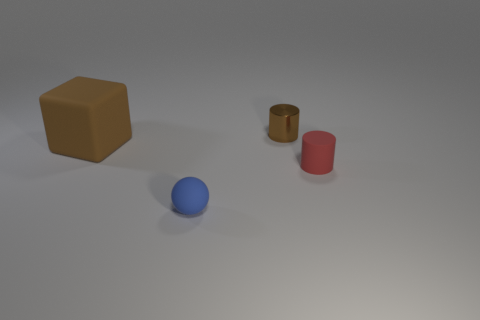Add 2 tiny cyan things. How many objects exist? 6 Subtract all cubes. How many objects are left? 3 Subtract 0 purple balls. How many objects are left? 4 Subtract all large cubes. Subtract all small yellow metallic cylinders. How many objects are left? 3 Add 1 small matte balls. How many small matte balls are left? 2 Add 2 large rubber blocks. How many large rubber blocks exist? 3 